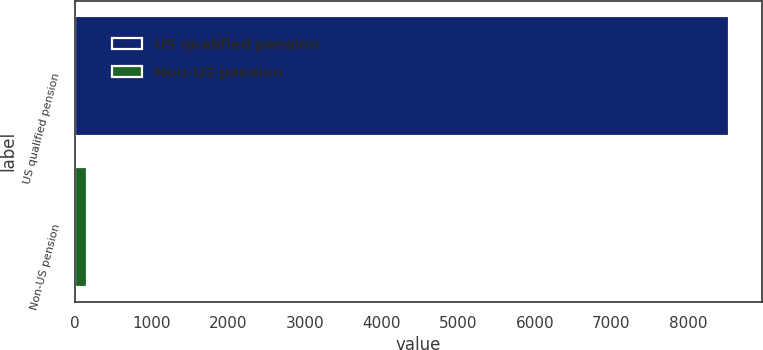Convert chart to OTSL. <chart><loc_0><loc_0><loc_500><loc_500><bar_chart><fcel>US qualified pension<fcel>Non-US pension<nl><fcel>8540<fcel>162<nl></chart> 